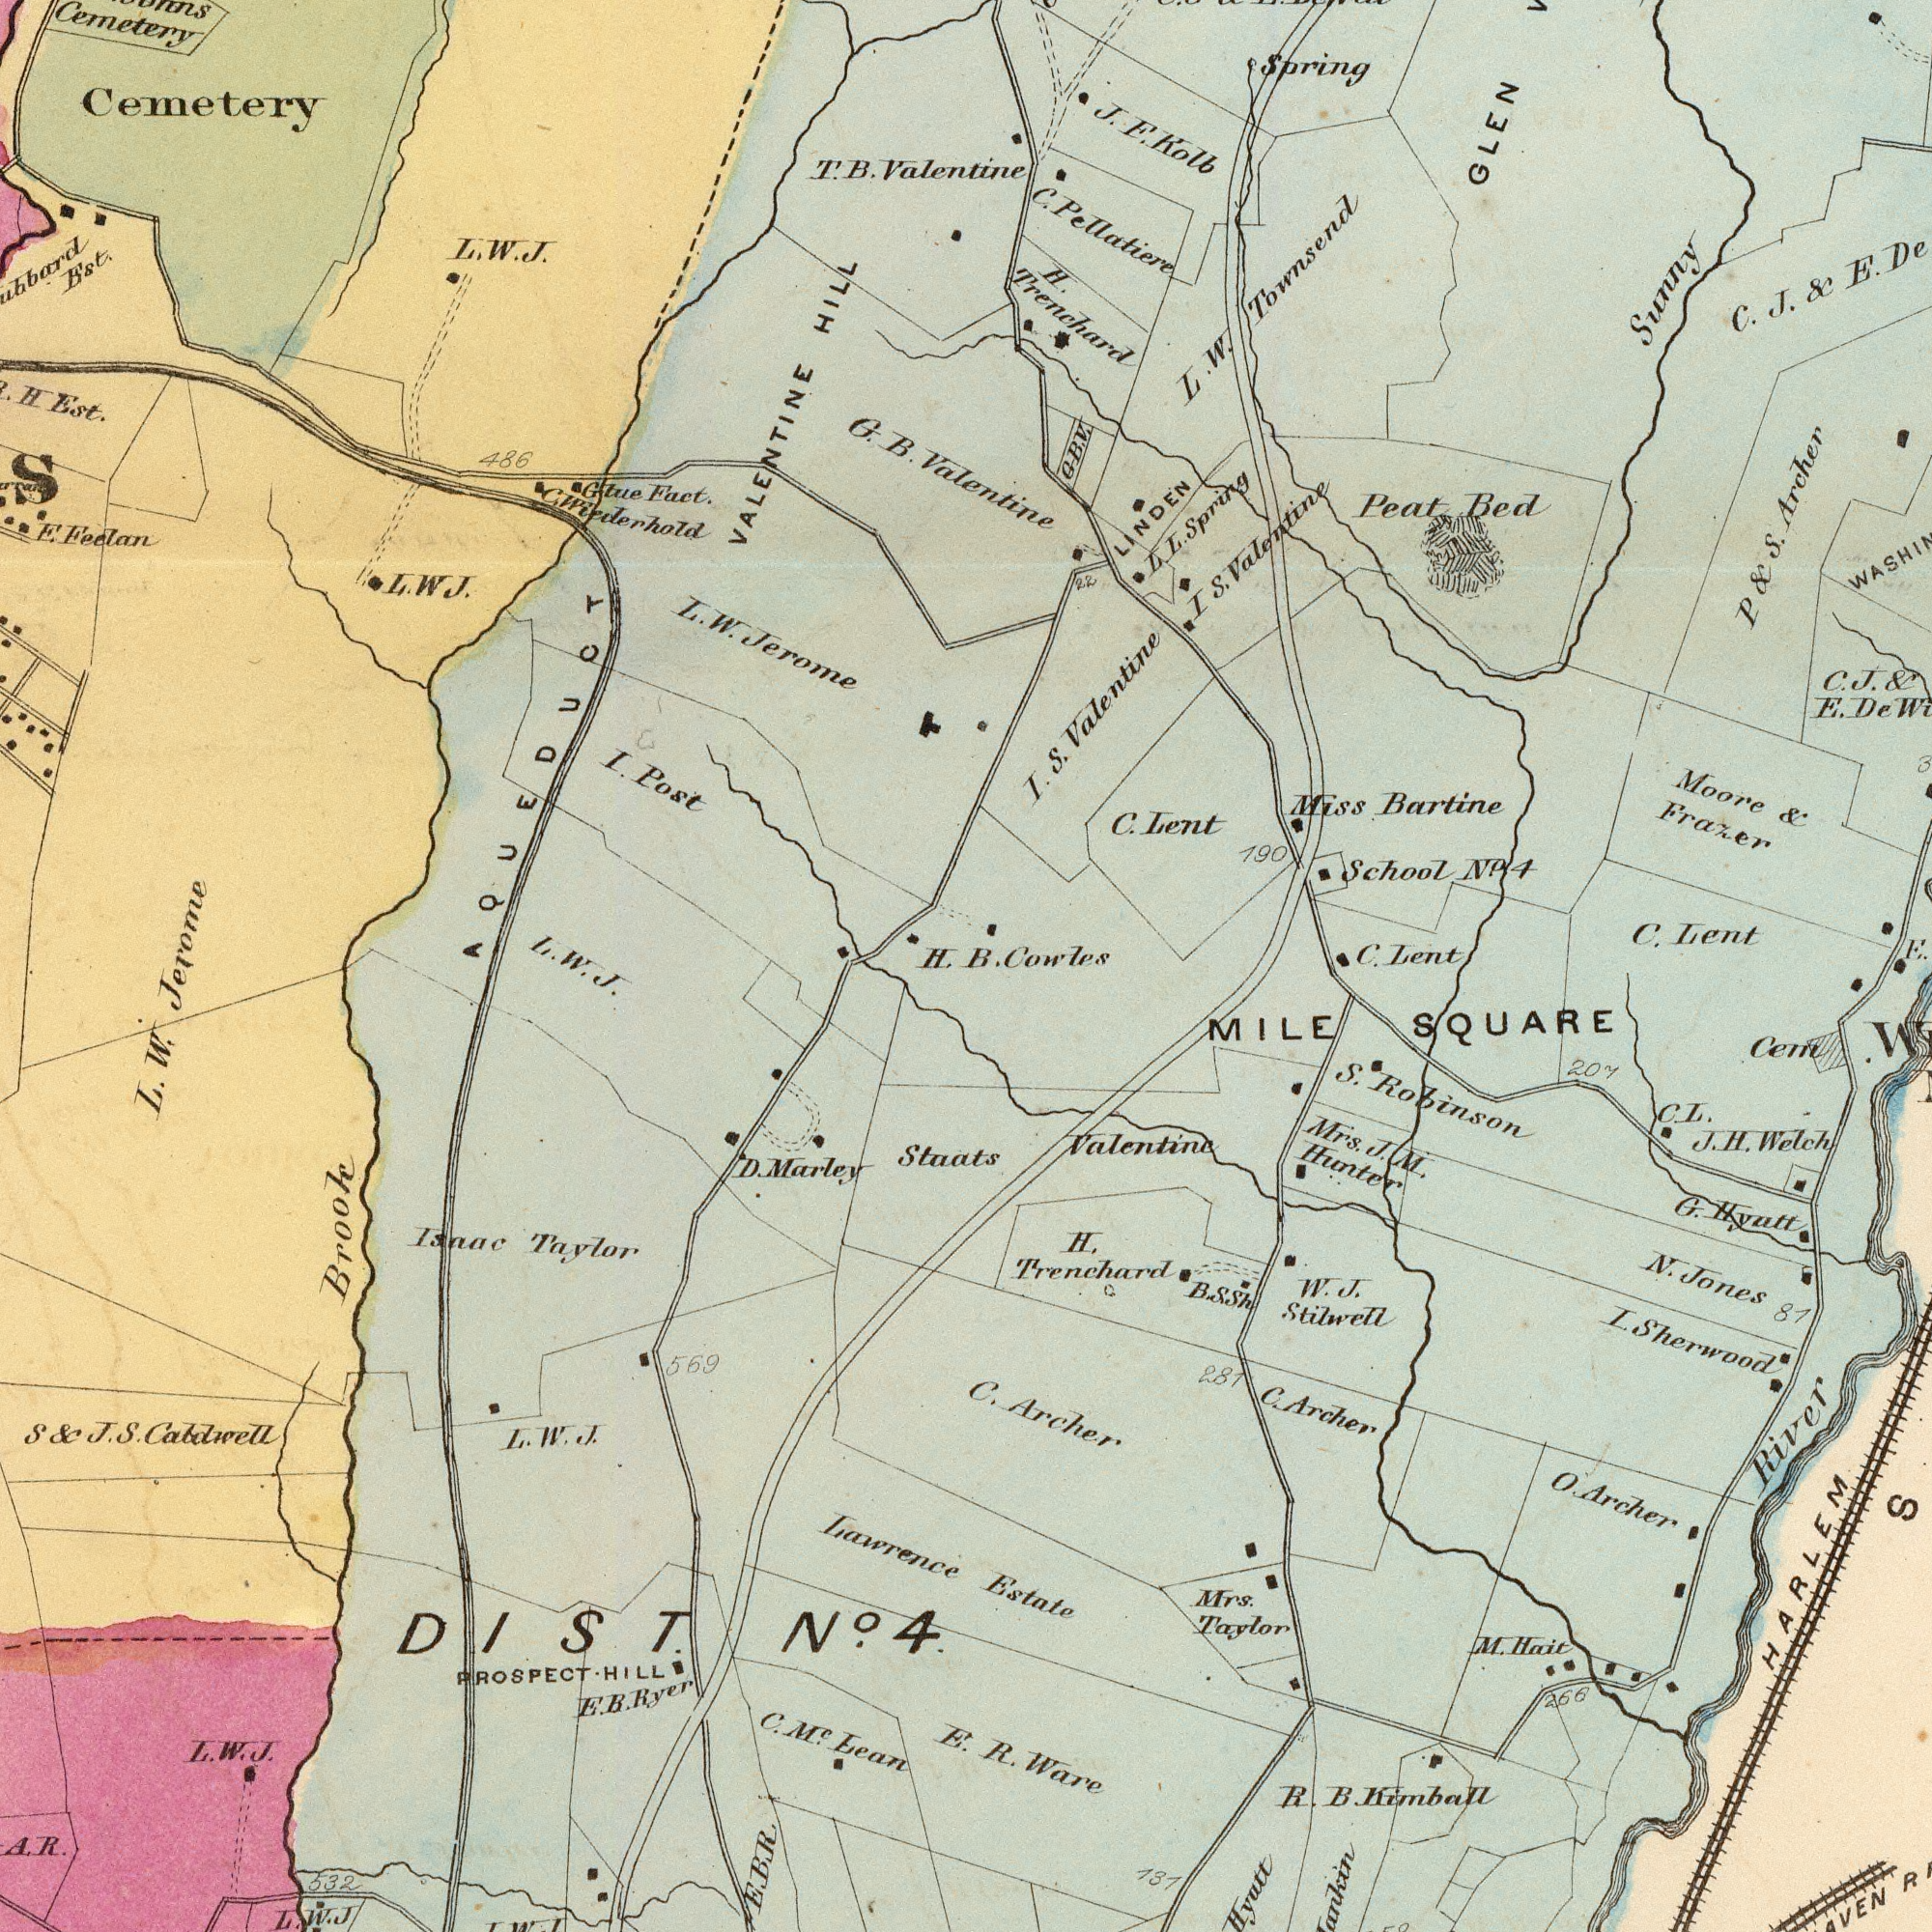What text appears in the top-right area of the image? Valentine I. S. Valentine C. Lent H. Trenchard L. W. Townsend C. Lent C. Lent School No 4 I S. Valentine C. J. & E. Moore & Frazer LINDEN P & S. Archer Peat Bed GLEN C. J. & E. De 190 Miss Bartine L. L. Spring J. F. Kolb 22 C. Pellatiere B. Cowles Spring G. B. V. Sunny What text can you see in the bottom-left section? Lawrence C. M<sup>c</sup>. Lean Isaac Taylor Staats D. Marley J. PROSPECT HILL L. W. J Brook S J. S. Cabdwell 532 E. 569 L. W. L. W. J. DIST. No. 4 E. B. Ryer L. W. J. A. R. E. B. R. What text can you see in the top-left section? AQUEDUCT VALENTINE HILL Cemetery I. Post Glue Fact. E. Feelan H. Est. Est. 486 G. B. T. T. Valentine L. W. Jerome L. W. J. H. L. W. Jerome Cemetery L. W J. C. Wiederhold What text can you see in the bottom-right section? Estate Valentine R. Ware S. Robinson H. Trenchard C. Archer L. Sherwood Mrs. J. M. Hunter MILE SQUARE HARLEM Hyatt G. Hyutt Cem C. Archer C. L. J. H. Welch W. J. Stilwell O. Archer M. Hait R. B. Kimball 207 Mrs. Taylor 131 266 281 81 N. Jones River B. S. Sh S 